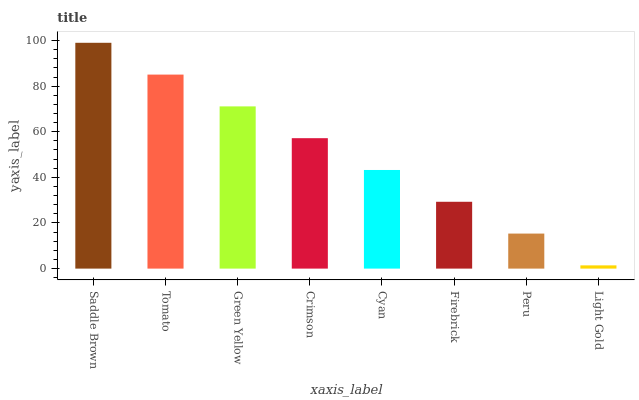Is Light Gold the minimum?
Answer yes or no. Yes. Is Saddle Brown the maximum?
Answer yes or no. Yes. Is Tomato the minimum?
Answer yes or no. No. Is Tomato the maximum?
Answer yes or no. No. Is Saddle Brown greater than Tomato?
Answer yes or no. Yes. Is Tomato less than Saddle Brown?
Answer yes or no. Yes. Is Tomato greater than Saddle Brown?
Answer yes or no. No. Is Saddle Brown less than Tomato?
Answer yes or no. No. Is Crimson the high median?
Answer yes or no. Yes. Is Cyan the low median?
Answer yes or no. Yes. Is Light Gold the high median?
Answer yes or no. No. Is Firebrick the low median?
Answer yes or no. No. 